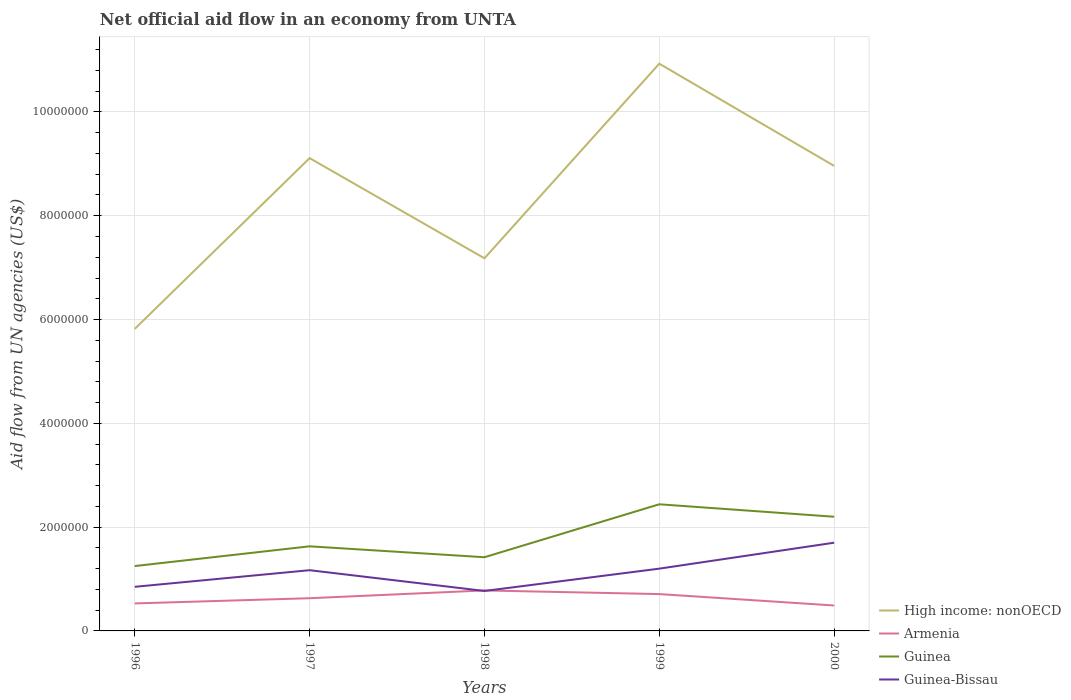How many different coloured lines are there?
Offer a very short reply. 4. Does the line corresponding to Guinea-Bissau intersect with the line corresponding to High income: nonOECD?
Keep it short and to the point. No. Is the number of lines equal to the number of legend labels?
Your answer should be very brief. Yes. Across all years, what is the maximum net official aid flow in High income: nonOECD?
Give a very brief answer. 5.82e+06. What is the total net official aid flow in Guinea-Bissau in the graph?
Ensure brevity in your answer.  -3.50e+05. What is the difference between the highest and the second highest net official aid flow in High income: nonOECD?
Give a very brief answer. 5.11e+06. What is the difference between the highest and the lowest net official aid flow in Guinea?
Provide a succinct answer. 2. Is the net official aid flow in Guinea-Bissau strictly greater than the net official aid flow in Armenia over the years?
Provide a succinct answer. No. How many lines are there?
Provide a short and direct response. 4. How many years are there in the graph?
Your response must be concise. 5. What is the difference between two consecutive major ticks on the Y-axis?
Make the answer very short. 2.00e+06. Are the values on the major ticks of Y-axis written in scientific E-notation?
Provide a succinct answer. No. How many legend labels are there?
Ensure brevity in your answer.  4. How are the legend labels stacked?
Keep it short and to the point. Vertical. What is the title of the graph?
Give a very brief answer. Net official aid flow in an economy from UNTA. What is the label or title of the X-axis?
Provide a succinct answer. Years. What is the label or title of the Y-axis?
Provide a succinct answer. Aid flow from UN agencies (US$). What is the Aid flow from UN agencies (US$) in High income: nonOECD in 1996?
Offer a very short reply. 5.82e+06. What is the Aid flow from UN agencies (US$) of Armenia in 1996?
Your response must be concise. 5.30e+05. What is the Aid flow from UN agencies (US$) in Guinea in 1996?
Offer a very short reply. 1.25e+06. What is the Aid flow from UN agencies (US$) in Guinea-Bissau in 1996?
Offer a terse response. 8.50e+05. What is the Aid flow from UN agencies (US$) in High income: nonOECD in 1997?
Offer a terse response. 9.11e+06. What is the Aid flow from UN agencies (US$) in Armenia in 1997?
Your answer should be compact. 6.30e+05. What is the Aid flow from UN agencies (US$) of Guinea in 1997?
Give a very brief answer. 1.63e+06. What is the Aid flow from UN agencies (US$) of Guinea-Bissau in 1997?
Offer a very short reply. 1.17e+06. What is the Aid flow from UN agencies (US$) in High income: nonOECD in 1998?
Your answer should be compact. 7.18e+06. What is the Aid flow from UN agencies (US$) in Armenia in 1998?
Offer a very short reply. 7.80e+05. What is the Aid flow from UN agencies (US$) in Guinea in 1998?
Keep it short and to the point. 1.42e+06. What is the Aid flow from UN agencies (US$) in Guinea-Bissau in 1998?
Provide a succinct answer. 7.70e+05. What is the Aid flow from UN agencies (US$) of High income: nonOECD in 1999?
Offer a very short reply. 1.09e+07. What is the Aid flow from UN agencies (US$) in Armenia in 1999?
Ensure brevity in your answer.  7.10e+05. What is the Aid flow from UN agencies (US$) of Guinea in 1999?
Your response must be concise. 2.44e+06. What is the Aid flow from UN agencies (US$) in Guinea-Bissau in 1999?
Provide a succinct answer. 1.20e+06. What is the Aid flow from UN agencies (US$) in High income: nonOECD in 2000?
Keep it short and to the point. 8.96e+06. What is the Aid flow from UN agencies (US$) of Guinea in 2000?
Provide a short and direct response. 2.20e+06. What is the Aid flow from UN agencies (US$) of Guinea-Bissau in 2000?
Your response must be concise. 1.70e+06. Across all years, what is the maximum Aid flow from UN agencies (US$) of High income: nonOECD?
Offer a very short reply. 1.09e+07. Across all years, what is the maximum Aid flow from UN agencies (US$) of Armenia?
Offer a terse response. 7.80e+05. Across all years, what is the maximum Aid flow from UN agencies (US$) of Guinea?
Provide a short and direct response. 2.44e+06. Across all years, what is the maximum Aid flow from UN agencies (US$) in Guinea-Bissau?
Ensure brevity in your answer.  1.70e+06. Across all years, what is the minimum Aid flow from UN agencies (US$) of High income: nonOECD?
Keep it short and to the point. 5.82e+06. Across all years, what is the minimum Aid flow from UN agencies (US$) of Guinea?
Your answer should be very brief. 1.25e+06. Across all years, what is the minimum Aid flow from UN agencies (US$) in Guinea-Bissau?
Offer a very short reply. 7.70e+05. What is the total Aid flow from UN agencies (US$) of High income: nonOECD in the graph?
Give a very brief answer. 4.20e+07. What is the total Aid flow from UN agencies (US$) in Armenia in the graph?
Your response must be concise. 3.14e+06. What is the total Aid flow from UN agencies (US$) in Guinea in the graph?
Ensure brevity in your answer.  8.94e+06. What is the total Aid flow from UN agencies (US$) in Guinea-Bissau in the graph?
Your answer should be very brief. 5.69e+06. What is the difference between the Aid flow from UN agencies (US$) in High income: nonOECD in 1996 and that in 1997?
Offer a very short reply. -3.29e+06. What is the difference between the Aid flow from UN agencies (US$) in Guinea in 1996 and that in 1997?
Keep it short and to the point. -3.80e+05. What is the difference between the Aid flow from UN agencies (US$) in Guinea-Bissau in 1996 and that in 1997?
Your answer should be compact. -3.20e+05. What is the difference between the Aid flow from UN agencies (US$) in High income: nonOECD in 1996 and that in 1998?
Offer a terse response. -1.36e+06. What is the difference between the Aid flow from UN agencies (US$) of Guinea in 1996 and that in 1998?
Provide a short and direct response. -1.70e+05. What is the difference between the Aid flow from UN agencies (US$) in Guinea-Bissau in 1996 and that in 1998?
Offer a very short reply. 8.00e+04. What is the difference between the Aid flow from UN agencies (US$) in High income: nonOECD in 1996 and that in 1999?
Make the answer very short. -5.11e+06. What is the difference between the Aid flow from UN agencies (US$) of Armenia in 1996 and that in 1999?
Give a very brief answer. -1.80e+05. What is the difference between the Aid flow from UN agencies (US$) in Guinea in 1996 and that in 1999?
Offer a terse response. -1.19e+06. What is the difference between the Aid flow from UN agencies (US$) of Guinea-Bissau in 1996 and that in 1999?
Offer a very short reply. -3.50e+05. What is the difference between the Aid flow from UN agencies (US$) of High income: nonOECD in 1996 and that in 2000?
Make the answer very short. -3.14e+06. What is the difference between the Aid flow from UN agencies (US$) in Guinea in 1996 and that in 2000?
Offer a terse response. -9.50e+05. What is the difference between the Aid flow from UN agencies (US$) in Guinea-Bissau in 1996 and that in 2000?
Offer a terse response. -8.50e+05. What is the difference between the Aid flow from UN agencies (US$) in High income: nonOECD in 1997 and that in 1998?
Ensure brevity in your answer.  1.93e+06. What is the difference between the Aid flow from UN agencies (US$) in Armenia in 1997 and that in 1998?
Provide a short and direct response. -1.50e+05. What is the difference between the Aid flow from UN agencies (US$) in Guinea in 1997 and that in 1998?
Provide a succinct answer. 2.10e+05. What is the difference between the Aid flow from UN agencies (US$) in Guinea-Bissau in 1997 and that in 1998?
Keep it short and to the point. 4.00e+05. What is the difference between the Aid flow from UN agencies (US$) in High income: nonOECD in 1997 and that in 1999?
Offer a very short reply. -1.82e+06. What is the difference between the Aid flow from UN agencies (US$) of Guinea in 1997 and that in 1999?
Provide a succinct answer. -8.10e+05. What is the difference between the Aid flow from UN agencies (US$) of Guinea-Bissau in 1997 and that in 1999?
Your answer should be very brief. -3.00e+04. What is the difference between the Aid flow from UN agencies (US$) of Guinea in 1997 and that in 2000?
Provide a short and direct response. -5.70e+05. What is the difference between the Aid flow from UN agencies (US$) in Guinea-Bissau in 1997 and that in 2000?
Give a very brief answer. -5.30e+05. What is the difference between the Aid flow from UN agencies (US$) in High income: nonOECD in 1998 and that in 1999?
Make the answer very short. -3.75e+06. What is the difference between the Aid flow from UN agencies (US$) in Guinea in 1998 and that in 1999?
Give a very brief answer. -1.02e+06. What is the difference between the Aid flow from UN agencies (US$) of Guinea-Bissau in 1998 and that in 1999?
Your answer should be compact. -4.30e+05. What is the difference between the Aid flow from UN agencies (US$) in High income: nonOECD in 1998 and that in 2000?
Your answer should be very brief. -1.78e+06. What is the difference between the Aid flow from UN agencies (US$) in Armenia in 1998 and that in 2000?
Make the answer very short. 2.90e+05. What is the difference between the Aid flow from UN agencies (US$) of Guinea in 1998 and that in 2000?
Offer a terse response. -7.80e+05. What is the difference between the Aid flow from UN agencies (US$) in Guinea-Bissau in 1998 and that in 2000?
Give a very brief answer. -9.30e+05. What is the difference between the Aid flow from UN agencies (US$) of High income: nonOECD in 1999 and that in 2000?
Your answer should be compact. 1.97e+06. What is the difference between the Aid flow from UN agencies (US$) in Armenia in 1999 and that in 2000?
Your answer should be very brief. 2.20e+05. What is the difference between the Aid flow from UN agencies (US$) of Guinea-Bissau in 1999 and that in 2000?
Offer a very short reply. -5.00e+05. What is the difference between the Aid flow from UN agencies (US$) of High income: nonOECD in 1996 and the Aid flow from UN agencies (US$) of Armenia in 1997?
Your response must be concise. 5.19e+06. What is the difference between the Aid flow from UN agencies (US$) in High income: nonOECD in 1996 and the Aid flow from UN agencies (US$) in Guinea in 1997?
Ensure brevity in your answer.  4.19e+06. What is the difference between the Aid flow from UN agencies (US$) in High income: nonOECD in 1996 and the Aid flow from UN agencies (US$) in Guinea-Bissau in 1997?
Your answer should be compact. 4.65e+06. What is the difference between the Aid flow from UN agencies (US$) of Armenia in 1996 and the Aid flow from UN agencies (US$) of Guinea in 1997?
Your response must be concise. -1.10e+06. What is the difference between the Aid flow from UN agencies (US$) of Armenia in 1996 and the Aid flow from UN agencies (US$) of Guinea-Bissau in 1997?
Provide a short and direct response. -6.40e+05. What is the difference between the Aid flow from UN agencies (US$) of Guinea in 1996 and the Aid flow from UN agencies (US$) of Guinea-Bissau in 1997?
Ensure brevity in your answer.  8.00e+04. What is the difference between the Aid flow from UN agencies (US$) in High income: nonOECD in 1996 and the Aid flow from UN agencies (US$) in Armenia in 1998?
Offer a terse response. 5.04e+06. What is the difference between the Aid flow from UN agencies (US$) in High income: nonOECD in 1996 and the Aid flow from UN agencies (US$) in Guinea in 1998?
Offer a very short reply. 4.40e+06. What is the difference between the Aid flow from UN agencies (US$) in High income: nonOECD in 1996 and the Aid flow from UN agencies (US$) in Guinea-Bissau in 1998?
Your response must be concise. 5.05e+06. What is the difference between the Aid flow from UN agencies (US$) of Armenia in 1996 and the Aid flow from UN agencies (US$) of Guinea in 1998?
Make the answer very short. -8.90e+05. What is the difference between the Aid flow from UN agencies (US$) in Guinea in 1996 and the Aid flow from UN agencies (US$) in Guinea-Bissau in 1998?
Offer a terse response. 4.80e+05. What is the difference between the Aid flow from UN agencies (US$) in High income: nonOECD in 1996 and the Aid flow from UN agencies (US$) in Armenia in 1999?
Give a very brief answer. 5.11e+06. What is the difference between the Aid flow from UN agencies (US$) of High income: nonOECD in 1996 and the Aid flow from UN agencies (US$) of Guinea in 1999?
Give a very brief answer. 3.38e+06. What is the difference between the Aid flow from UN agencies (US$) in High income: nonOECD in 1996 and the Aid flow from UN agencies (US$) in Guinea-Bissau in 1999?
Provide a short and direct response. 4.62e+06. What is the difference between the Aid flow from UN agencies (US$) in Armenia in 1996 and the Aid flow from UN agencies (US$) in Guinea in 1999?
Provide a short and direct response. -1.91e+06. What is the difference between the Aid flow from UN agencies (US$) in Armenia in 1996 and the Aid flow from UN agencies (US$) in Guinea-Bissau in 1999?
Your response must be concise. -6.70e+05. What is the difference between the Aid flow from UN agencies (US$) of Guinea in 1996 and the Aid flow from UN agencies (US$) of Guinea-Bissau in 1999?
Give a very brief answer. 5.00e+04. What is the difference between the Aid flow from UN agencies (US$) in High income: nonOECD in 1996 and the Aid flow from UN agencies (US$) in Armenia in 2000?
Make the answer very short. 5.33e+06. What is the difference between the Aid flow from UN agencies (US$) in High income: nonOECD in 1996 and the Aid flow from UN agencies (US$) in Guinea in 2000?
Keep it short and to the point. 3.62e+06. What is the difference between the Aid flow from UN agencies (US$) in High income: nonOECD in 1996 and the Aid flow from UN agencies (US$) in Guinea-Bissau in 2000?
Make the answer very short. 4.12e+06. What is the difference between the Aid flow from UN agencies (US$) of Armenia in 1996 and the Aid flow from UN agencies (US$) of Guinea in 2000?
Provide a succinct answer. -1.67e+06. What is the difference between the Aid flow from UN agencies (US$) in Armenia in 1996 and the Aid flow from UN agencies (US$) in Guinea-Bissau in 2000?
Your response must be concise. -1.17e+06. What is the difference between the Aid flow from UN agencies (US$) in Guinea in 1996 and the Aid flow from UN agencies (US$) in Guinea-Bissau in 2000?
Your answer should be very brief. -4.50e+05. What is the difference between the Aid flow from UN agencies (US$) of High income: nonOECD in 1997 and the Aid flow from UN agencies (US$) of Armenia in 1998?
Provide a succinct answer. 8.33e+06. What is the difference between the Aid flow from UN agencies (US$) of High income: nonOECD in 1997 and the Aid flow from UN agencies (US$) of Guinea in 1998?
Your answer should be compact. 7.69e+06. What is the difference between the Aid flow from UN agencies (US$) of High income: nonOECD in 1997 and the Aid flow from UN agencies (US$) of Guinea-Bissau in 1998?
Provide a short and direct response. 8.34e+06. What is the difference between the Aid flow from UN agencies (US$) in Armenia in 1997 and the Aid flow from UN agencies (US$) in Guinea in 1998?
Make the answer very short. -7.90e+05. What is the difference between the Aid flow from UN agencies (US$) in Guinea in 1997 and the Aid flow from UN agencies (US$) in Guinea-Bissau in 1998?
Your answer should be compact. 8.60e+05. What is the difference between the Aid flow from UN agencies (US$) in High income: nonOECD in 1997 and the Aid flow from UN agencies (US$) in Armenia in 1999?
Ensure brevity in your answer.  8.40e+06. What is the difference between the Aid flow from UN agencies (US$) in High income: nonOECD in 1997 and the Aid flow from UN agencies (US$) in Guinea in 1999?
Your response must be concise. 6.67e+06. What is the difference between the Aid flow from UN agencies (US$) in High income: nonOECD in 1997 and the Aid flow from UN agencies (US$) in Guinea-Bissau in 1999?
Your response must be concise. 7.91e+06. What is the difference between the Aid flow from UN agencies (US$) of Armenia in 1997 and the Aid flow from UN agencies (US$) of Guinea in 1999?
Ensure brevity in your answer.  -1.81e+06. What is the difference between the Aid flow from UN agencies (US$) in Armenia in 1997 and the Aid flow from UN agencies (US$) in Guinea-Bissau in 1999?
Give a very brief answer. -5.70e+05. What is the difference between the Aid flow from UN agencies (US$) in High income: nonOECD in 1997 and the Aid flow from UN agencies (US$) in Armenia in 2000?
Ensure brevity in your answer.  8.62e+06. What is the difference between the Aid flow from UN agencies (US$) of High income: nonOECD in 1997 and the Aid flow from UN agencies (US$) of Guinea in 2000?
Ensure brevity in your answer.  6.91e+06. What is the difference between the Aid flow from UN agencies (US$) in High income: nonOECD in 1997 and the Aid flow from UN agencies (US$) in Guinea-Bissau in 2000?
Offer a terse response. 7.41e+06. What is the difference between the Aid flow from UN agencies (US$) in Armenia in 1997 and the Aid flow from UN agencies (US$) in Guinea in 2000?
Keep it short and to the point. -1.57e+06. What is the difference between the Aid flow from UN agencies (US$) of Armenia in 1997 and the Aid flow from UN agencies (US$) of Guinea-Bissau in 2000?
Offer a terse response. -1.07e+06. What is the difference between the Aid flow from UN agencies (US$) in High income: nonOECD in 1998 and the Aid flow from UN agencies (US$) in Armenia in 1999?
Give a very brief answer. 6.47e+06. What is the difference between the Aid flow from UN agencies (US$) of High income: nonOECD in 1998 and the Aid flow from UN agencies (US$) of Guinea in 1999?
Your response must be concise. 4.74e+06. What is the difference between the Aid flow from UN agencies (US$) in High income: nonOECD in 1998 and the Aid flow from UN agencies (US$) in Guinea-Bissau in 1999?
Offer a terse response. 5.98e+06. What is the difference between the Aid flow from UN agencies (US$) in Armenia in 1998 and the Aid flow from UN agencies (US$) in Guinea in 1999?
Keep it short and to the point. -1.66e+06. What is the difference between the Aid flow from UN agencies (US$) of Armenia in 1998 and the Aid flow from UN agencies (US$) of Guinea-Bissau in 1999?
Your answer should be very brief. -4.20e+05. What is the difference between the Aid flow from UN agencies (US$) in Guinea in 1998 and the Aid flow from UN agencies (US$) in Guinea-Bissau in 1999?
Your answer should be very brief. 2.20e+05. What is the difference between the Aid flow from UN agencies (US$) of High income: nonOECD in 1998 and the Aid flow from UN agencies (US$) of Armenia in 2000?
Keep it short and to the point. 6.69e+06. What is the difference between the Aid flow from UN agencies (US$) in High income: nonOECD in 1998 and the Aid flow from UN agencies (US$) in Guinea in 2000?
Your answer should be compact. 4.98e+06. What is the difference between the Aid flow from UN agencies (US$) in High income: nonOECD in 1998 and the Aid flow from UN agencies (US$) in Guinea-Bissau in 2000?
Your response must be concise. 5.48e+06. What is the difference between the Aid flow from UN agencies (US$) in Armenia in 1998 and the Aid flow from UN agencies (US$) in Guinea in 2000?
Make the answer very short. -1.42e+06. What is the difference between the Aid flow from UN agencies (US$) of Armenia in 1998 and the Aid flow from UN agencies (US$) of Guinea-Bissau in 2000?
Ensure brevity in your answer.  -9.20e+05. What is the difference between the Aid flow from UN agencies (US$) in Guinea in 1998 and the Aid flow from UN agencies (US$) in Guinea-Bissau in 2000?
Your answer should be very brief. -2.80e+05. What is the difference between the Aid flow from UN agencies (US$) of High income: nonOECD in 1999 and the Aid flow from UN agencies (US$) of Armenia in 2000?
Your answer should be compact. 1.04e+07. What is the difference between the Aid flow from UN agencies (US$) in High income: nonOECD in 1999 and the Aid flow from UN agencies (US$) in Guinea in 2000?
Give a very brief answer. 8.73e+06. What is the difference between the Aid flow from UN agencies (US$) in High income: nonOECD in 1999 and the Aid flow from UN agencies (US$) in Guinea-Bissau in 2000?
Offer a very short reply. 9.23e+06. What is the difference between the Aid flow from UN agencies (US$) in Armenia in 1999 and the Aid flow from UN agencies (US$) in Guinea in 2000?
Offer a very short reply. -1.49e+06. What is the difference between the Aid flow from UN agencies (US$) in Armenia in 1999 and the Aid flow from UN agencies (US$) in Guinea-Bissau in 2000?
Offer a terse response. -9.90e+05. What is the difference between the Aid flow from UN agencies (US$) in Guinea in 1999 and the Aid flow from UN agencies (US$) in Guinea-Bissau in 2000?
Give a very brief answer. 7.40e+05. What is the average Aid flow from UN agencies (US$) of High income: nonOECD per year?
Give a very brief answer. 8.40e+06. What is the average Aid flow from UN agencies (US$) in Armenia per year?
Your response must be concise. 6.28e+05. What is the average Aid flow from UN agencies (US$) in Guinea per year?
Give a very brief answer. 1.79e+06. What is the average Aid flow from UN agencies (US$) of Guinea-Bissau per year?
Provide a succinct answer. 1.14e+06. In the year 1996, what is the difference between the Aid flow from UN agencies (US$) of High income: nonOECD and Aid flow from UN agencies (US$) of Armenia?
Ensure brevity in your answer.  5.29e+06. In the year 1996, what is the difference between the Aid flow from UN agencies (US$) of High income: nonOECD and Aid flow from UN agencies (US$) of Guinea?
Your response must be concise. 4.57e+06. In the year 1996, what is the difference between the Aid flow from UN agencies (US$) in High income: nonOECD and Aid flow from UN agencies (US$) in Guinea-Bissau?
Keep it short and to the point. 4.97e+06. In the year 1996, what is the difference between the Aid flow from UN agencies (US$) of Armenia and Aid flow from UN agencies (US$) of Guinea?
Offer a very short reply. -7.20e+05. In the year 1996, what is the difference between the Aid flow from UN agencies (US$) in Armenia and Aid flow from UN agencies (US$) in Guinea-Bissau?
Give a very brief answer. -3.20e+05. In the year 1997, what is the difference between the Aid flow from UN agencies (US$) of High income: nonOECD and Aid flow from UN agencies (US$) of Armenia?
Give a very brief answer. 8.48e+06. In the year 1997, what is the difference between the Aid flow from UN agencies (US$) in High income: nonOECD and Aid flow from UN agencies (US$) in Guinea?
Give a very brief answer. 7.48e+06. In the year 1997, what is the difference between the Aid flow from UN agencies (US$) in High income: nonOECD and Aid flow from UN agencies (US$) in Guinea-Bissau?
Keep it short and to the point. 7.94e+06. In the year 1997, what is the difference between the Aid flow from UN agencies (US$) in Armenia and Aid flow from UN agencies (US$) in Guinea?
Your answer should be very brief. -1.00e+06. In the year 1997, what is the difference between the Aid flow from UN agencies (US$) in Armenia and Aid flow from UN agencies (US$) in Guinea-Bissau?
Your response must be concise. -5.40e+05. In the year 1998, what is the difference between the Aid flow from UN agencies (US$) of High income: nonOECD and Aid flow from UN agencies (US$) of Armenia?
Make the answer very short. 6.40e+06. In the year 1998, what is the difference between the Aid flow from UN agencies (US$) in High income: nonOECD and Aid flow from UN agencies (US$) in Guinea?
Offer a very short reply. 5.76e+06. In the year 1998, what is the difference between the Aid flow from UN agencies (US$) in High income: nonOECD and Aid flow from UN agencies (US$) in Guinea-Bissau?
Give a very brief answer. 6.41e+06. In the year 1998, what is the difference between the Aid flow from UN agencies (US$) of Armenia and Aid flow from UN agencies (US$) of Guinea?
Ensure brevity in your answer.  -6.40e+05. In the year 1998, what is the difference between the Aid flow from UN agencies (US$) of Armenia and Aid flow from UN agencies (US$) of Guinea-Bissau?
Your answer should be very brief. 10000. In the year 1998, what is the difference between the Aid flow from UN agencies (US$) in Guinea and Aid flow from UN agencies (US$) in Guinea-Bissau?
Offer a very short reply. 6.50e+05. In the year 1999, what is the difference between the Aid flow from UN agencies (US$) of High income: nonOECD and Aid flow from UN agencies (US$) of Armenia?
Provide a succinct answer. 1.02e+07. In the year 1999, what is the difference between the Aid flow from UN agencies (US$) of High income: nonOECD and Aid flow from UN agencies (US$) of Guinea?
Ensure brevity in your answer.  8.49e+06. In the year 1999, what is the difference between the Aid flow from UN agencies (US$) of High income: nonOECD and Aid flow from UN agencies (US$) of Guinea-Bissau?
Give a very brief answer. 9.73e+06. In the year 1999, what is the difference between the Aid flow from UN agencies (US$) in Armenia and Aid flow from UN agencies (US$) in Guinea?
Make the answer very short. -1.73e+06. In the year 1999, what is the difference between the Aid flow from UN agencies (US$) of Armenia and Aid flow from UN agencies (US$) of Guinea-Bissau?
Your response must be concise. -4.90e+05. In the year 1999, what is the difference between the Aid flow from UN agencies (US$) in Guinea and Aid flow from UN agencies (US$) in Guinea-Bissau?
Provide a succinct answer. 1.24e+06. In the year 2000, what is the difference between the Aid flow from UN agencies (US$) of High income: nonOECD and Aid flow from UN agencies (US$) of Armenia?
Your response must be concise. 8.47e+06. In the year 2000, what is the difference between the Aid flow from UN agencies (US$) in High income: nonOECD and Aid flow from UN agencies (US$) in Guinea?
Your answer should be very brief. 6.76e+06. In the year 2000, what is the difference between the Aid flow from UN agencies (US$) of High income: nonOECD and Aid flow from UN agencies (US$) of Guinea-Bissau?
Keep it short and to the point. 7.26e+06. In the year 2000, what is the difference between the Aid flow from UN agencies (US$) in Armenia and Aid flow from UN agencies (US$) in Guinea?
Your response must be concise. -1.71e+06. In the year 2000, what is the difference between the Aid flow from UN agencies (US$) of Armenia and Aid flow from UN agencies (US$) of Guinea-Bissau?
Provide a succinct answer. -1.21e+06. In the year 2000, what is the difference between the Aid flow from UN agencies (US$) of Guinea and Aid flow from UN agencies (US$) of Guinea-Bissau?
Keep it short and to the point. 5.00e+05. What is the ratio of the Aid flow from UN agencies (US$) in High income: nonOECD in 1996 to that in 1997?
Your response must be concise. 0.64. What is the ratio of the Aid flow from UN agencies (US$) of Armenia in 1996 to that in 1997?
Provide a succinct answer. 0.84. What is the ratio of the Aid flow from UN agencies (US$) in Guinea in 1996 to that in 1997?
Offer a very short reply. 0.77. What is the ratio of the Aid flow from UN agencies (US$) of Guinea-Bissau in 1996 to that in 1997?
Provide a succinct answer. 0.73. What is the ratio of the Aid flow from UN agencies (US$) of High income: nonOECD in 1996 to that in 1998?
Your answer should be compact. 0.81. What is the ratio of the Aid flow from UN agencies (US$) in Armenia in 1996 to that in 1998?
Provide a short and direct response. 0.68. What is the ratio of the Aid flow from UN agencies (US$) in Guinea in 1996 to that in 1998?
Offer a terse response. 0.88. What is the ratio of the Aid flow from UN agencies (US$) in Guinea-Bissau in 1996 to that in 1998?
Your response must be concise. 1.1. What is the ratio of the Aid flow from UN agencies (US$) in High income: nonOECD in 1996 to that in 1999?
Make the answer very short. 0.53. What is the ratio of the Aid flow from UN agencies (US$) in Armenia in 1996 to that in 1999?
Your answer should be compact. 0.75. What is the ratio of the Aid flow from UN agencies (US$) in Guinea in 1996 to that in 1999?
Offer a terse response. 0.51. What is the ratio of the Aid flow from UN agencies (US$) in Guinea-Bissau in 1996 to that in 1999?
Keep it short and to the point. 0.71. What is the ratio of the Aid flow from UN agencies (US$) in High income: nonOECD in 1996 to that in 2000?
Make the answer very short. 0.65. What is the ratio of the Aid flow from UN agencies (US$) of Armenia in 1996 to that in 2000?
Provide a succinct answer. 1.08. What is the ratio of the Aid flow from UN agencies (US$) of Guinea in 1996 to that in 2000?
Make the answer very short. 0.57. What is the ratio of the Aid flow from UN agencies (US$) in Guinea-Bissau in 1996 to that in 2000?
Make the answer very short. 0.5. What is the ratio of the Aid flow from UN agencies (US$) in High income: nonOECD in 1997 to that in 1998?
Offer a very short reply. 1.27. What is the ratio of the Aid flow from UN agencies (US$) in Armenia in 1997 to that in 1998?
Your answer should be very brief. 0.81. What is the ratio of the Aid flow from UN agencies (US$) in Guinea in 1997 to that in 1998?
Provide a succinct answer. 1.15. What is the ratio of the Aid flow from UN agencies (US$) in Guinea-Bissau in 1997 to that in 1998?
Your response must be concise. 1.52. What is the ratio of the Aid flow from UN agencies (US$) in High income: nonOECD in 1997 to that in 1999?
Keep it short and to the point. 0.83. What is the ratio of the Aid flow from UN agencies (US$) of Armenia in 1997 to that in 1999?
Ensure brevity in your answer.  0.89. What is the ratio of the Aid flow from UN agencies (US$) in Guinea in 1997 to that in 1999?
Make the answer very short. 0.67. What is the ratio of the Aid flow from UN agencies (US$) of High income: nonOECD in 1997 to that in 2000?
Provide a succinct answer. 1.02. What is the ratio of the Aid flow from UN agencies (US$) in Armenia in 1997 to that in 2000?
Your answer should be compact. 1.29. What is the ratio of the Aid flow from UN agencies (US$) in Guinea in 1997 to that in 2000?
Your response must be concise. 0.74. What is the ratio of the Aid flow from UN agencies (US$) in Guinea-Bissau in 1997 to that in 2000?
Offer a terse response. 0.69. What is the ratio of the Aid flow from UN agencies (US$) in High income: nonOECD in 1998 to that in 1999?
Give a very brief answer. 0.66. What is the ratio of the Aid flow from UN agencies (US$) of Armenia in 1998 to that in 1999?
Provide a succinct answer. 1.1. What is the ratio of the Aid flow from UN agencies (US$) of Guinea in 1998 to that in 1999?
Give a very brief answer. 0.58. What is the ratio of the Aid flow from UN agencies (US$) of Guinea-Bissau in 1998 to that in 1999?
Give a very brief answer. 0.64. What is the ratio of the Aid flow from UN agencies (US$) of High income: nonOECD in 1998 to that in 2000?
Offer a very short reply. 0.8. What is the ratio of the Aid flow from UN agencies (US$) in Armenia in 1998 to that in 2000?
Your answer should be very brief. 1.59. What is the ratio of the Aid flow from UN agencies (US$) of Guinea in 1998 to that in 2000?
Offer a very short reply. 0.65. What is the ratio of the Aid flow from UN agencies (US$) of Guinea-Bissau in 1998 to that in 2000?
Provide a short and direct response. 0.45. What is the ratio of the Aid flow from UN agencies (US$) in High income: nonOECD in 1999 to that in 2000?
Offer a very short reply. 1.22. What is the ratio of the Aid flow from UN agencies (US$) of Armenia in 1999 to that in 2000?
Provide a succinct answer. 1.45. What is the ratio of the Aid flow from UN agencies (US$) in Guinea in 1999 to that in 2000?
Ensure brevity in your answer.  1.11. What is the ratio of the Aid flow from UN agencies (US$) of Guinea-Bissau in 1999 to that in 2000?
Ensure brevity in your answer.  0.71. What is the difference between the highest and the second highest Aid flow from UN agencies (US$) in High income: nonOECD?
Provide a succinct answer. 1.82e+06. What is the difference between the highest and the second highest Aid flow from UN agencies (US$) of Guinea?
Offer a terse response. 2.40e+05. What is the difference between the highest and the lowest Aid flow from UN agencies (US$) in High income: nonOECD?
Your answer should be compact. 5.11e+06. What is the difference between the highest and the lowest Aid flow from UN agencies (US$) of Guinea?
Provide a short and direct response. 1.19e+06. What is the difference between the highest and the lowest Aid flow from UN agencies (US$) of Guinea-Bissau?
Provide a short and direct response. 9.30e+05. 